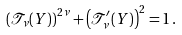Convert formula to latex. <formula><loc_0><loc_0><loc_500><loc_500>\left ( { \mathcal { T } } _ { \nu } ( Y ) \right ) ^ { 2 \nu } + \left ( { \mathcal { T } } _ { \nu } ^ { \prime } ( Y ) \right ) ^ { 2 } = 1 \, .</formula> 